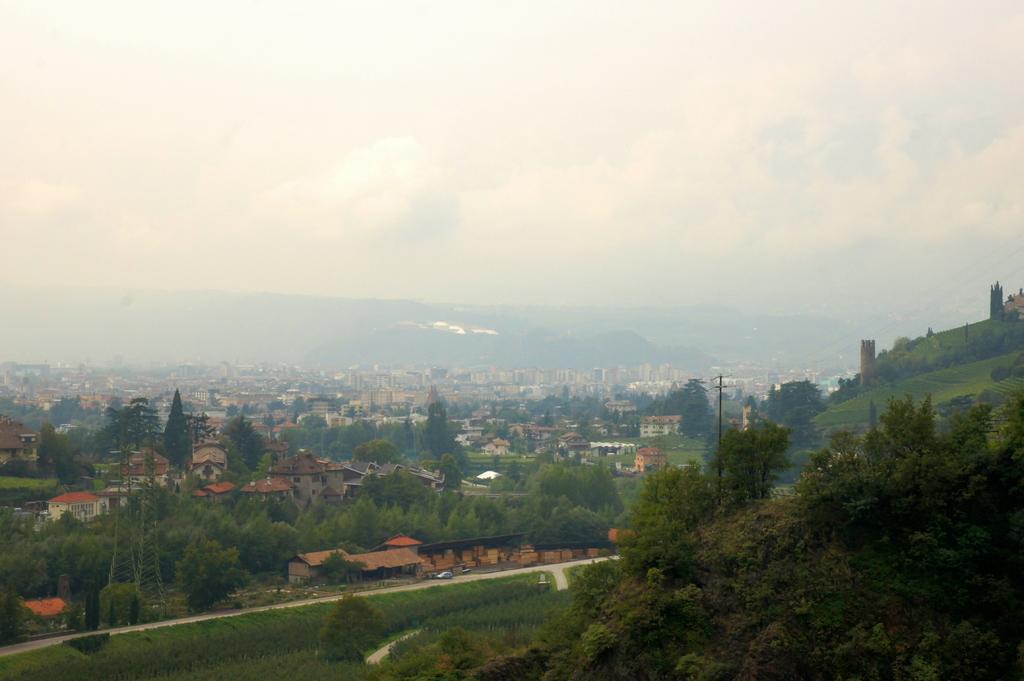How would you summarize this image in a sentence or two? In this image we can see many buildings and trees. In the background there are hills and sky. We can see a pole. There is a road and we can see a car on the road. 